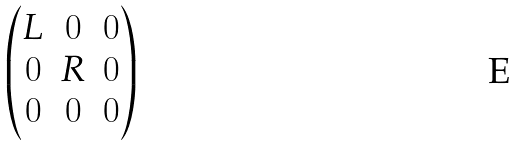Convert formula to latex. <formula><loc_0><loc_0><loc_500><loc_500>\begin{pmatrix} L & 0 & 0 \\ 0 & R & 0 \\ 0 & 0 & 0 \end{pmatrix}</formula> 